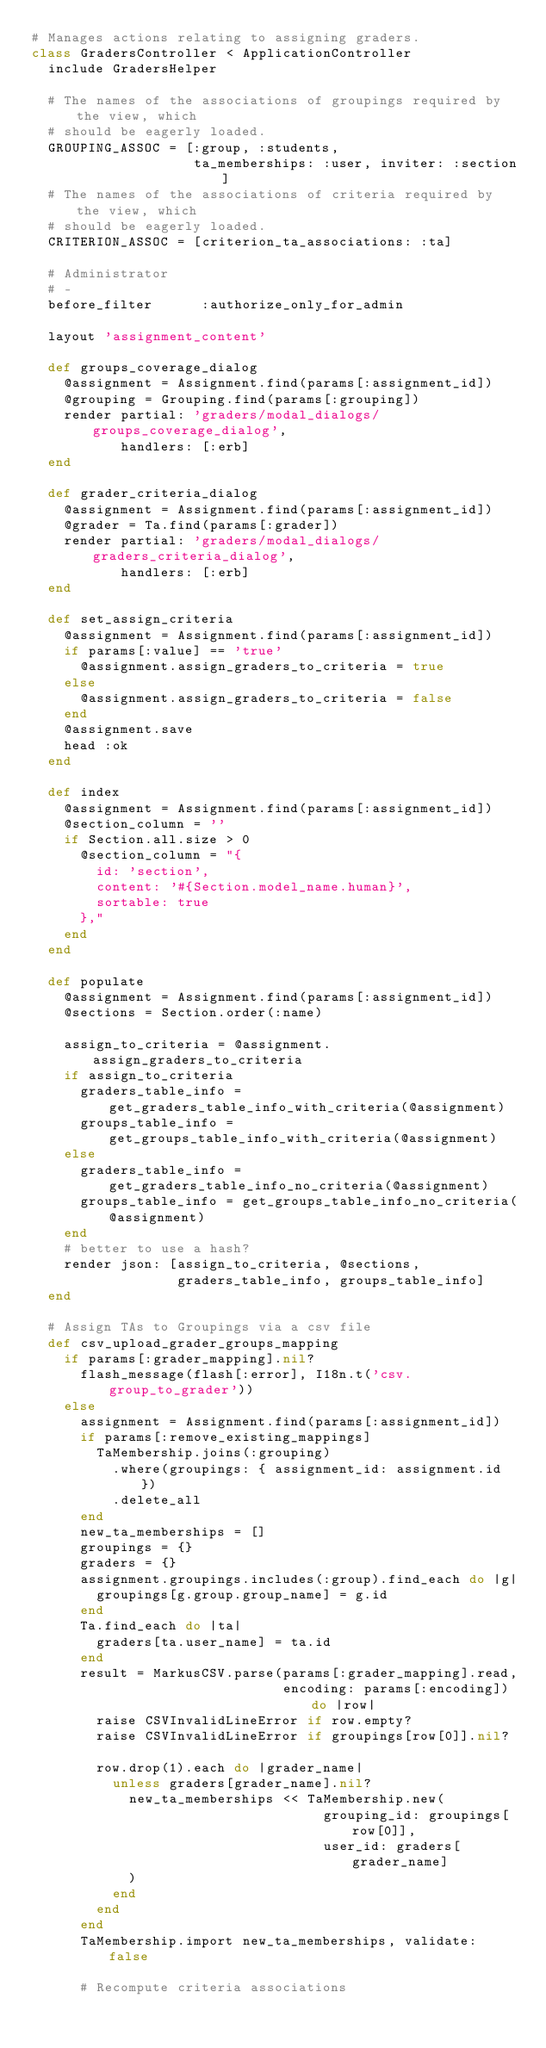Convert code to text. <code><loc_0><loc_0><loc_500><loc_500><_Ruby_># Manages actions relating to assigning graders.
class GradersController < ApplicationController
  include GradersHelper

  # The names of the associations of groupings required by the view, which
  # should be eagerly loaded.
  GROUPING_ASSOC = [:group, :students,
                    ta_memberships: :user, inviter: :section]
  # The names of the associations of criteria required by the view, which
  # should be eagerly loaded.
  CRITERION_ASSOC = [criterion_ta_associations: :ta]

  # Administrator
  # -
  before_filter      :authorize_only_for_admin

  layout 'assignment_content'

  def groups_coverage_dialog
    @assignment = Assignment.find(params[:assignment_id])
    @grouping = Grouping.find(params[:grouping])
    render partial: 'graders/modal_dialogs/groups_coverage_dialog',
           handlers: [:erb]
  end

  def grader_criteria_dialog
    @assignment = Assignment.find(params[:assignment_id])
    @grader = Ta.find(params[:grader])
    render partial: 'graders/modal_dialogs/graders_criteria_dialog',
           handlers: [:erb]
  end

  def set_assign_criteria
    @assignment = Assignment.find(params[:assignment_id])
    if params[:value] == 'true'
      @assignment.assign_graders_to_criteria = true
    else
      @assignment.assign_graders_to_criteria = false
    end
    @assignment.save
    head :ok
  end

  def index
    @assignment = Assignment.find(params[:assignment_id])
    @section_column = ''
    if Section.all.size > 0
      @section_column = "{
        id: 'section',
        content: '#{Section.model_name.human}',
        sortable: true
      },"
    end
  end

  def populate
    @assignment = Assignment.find(params[:assignment_id])
    @sections = Section.order(:name)

    assign_to_criteria = @assignment.assign_graders_to_criteria
    if assign_to_criteria
      graders_table_info = get_graders_table_info_with_criteria(@assignment)
      groups_table_info = get_groups_table_info_with_criteria(@assignment)
    else
      graders_table_info = get_graders_table_info_no_criteria(@assignment)
      groups_table_info = get_groups_table_info_no_criteria(@assignment)
    end
    # better to use a hash?
    render json: [assign_to_criteria, @sections,
                  graders_table_info, groups_table_info]
  end

  # Assign TAs to Groupings via a csv file
  def csv_upload_grader_groups_mapping
    if params[:grader_mapping].nil?
      flash_message(flash[:error], I18n.t('csv.group_to_grader'))
    else
      assignment = Assignment.find(params[:assignment_id])
      if params[:remove_existing_mappings]
        TaMembership.joins(:grouping)
          .where(groupings: { assignment_id: assignment.id })
          .delete_all
      end
      new_ta_memberships = []
      groupings = {}
      graders = {}
      assignment.groupings.includes(:group).find_each do |g|
        groupings[g.group.group_name] = g.id
      end
      Ta.find_each do |ta|
        graders[ta.user_name] = ta.id
      end
      result = MarkusCSV.parse(params[:grader_mapping].read,
                               encoding: params[:encoding]) do |row|
        raise CSVInvalidLineError if row.empty?
        raise CSVInvalidLineError if groupings[row[0]].nil?

        row.drop(1).each do |grader_name|
          unless graders[grader_name].nil?
            new_ta_memberships << TaMembership.new(
                                    grouping_id: groupings[row[0]],
                                    user_id: graders[grader_name]
            )
          end
        end
      end
      TaMembership.import new_ta_memberships, validate: false

      # Recompute criteria associations</code> 